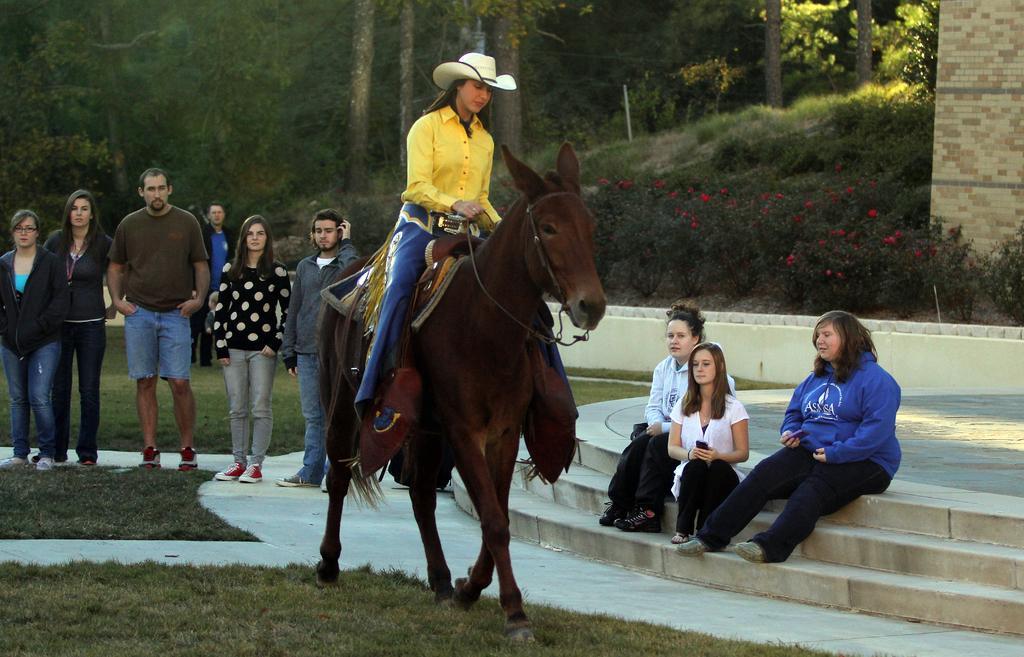Can you describe this image briefly? In this picture we can see a woman riding a horse, on right side there are three women sitting on stairs in the background of a group of people Standing and watching the woman there is a grass on the bottom, in the background trees and right side of the picture we can see some of the flower plants. 